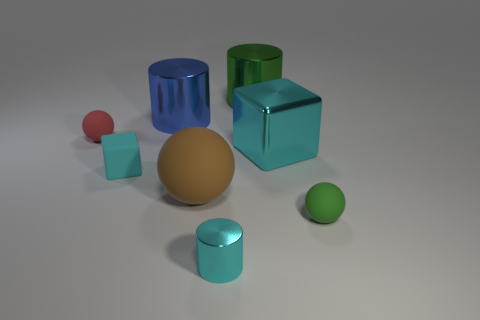Add 2 large gray things. How many objects exist? 10 Subtract all balls. How many objects are left? 5 Subtract all small cyan metal cylinders. Subtract all small red spheres. How many objects are left? 6 Add 2 big metallic things. How many big metallic things are left? 5 Add 3 large yellow cubes. How many large yellow cubes exist? 3 Subtract 1 cyan blocks. How many objects are left? 7 